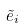Convert formula to latex. <formula><loc_0><loc_0><loc_500><loc_500>\tilde { e } _ { i }</formula> 